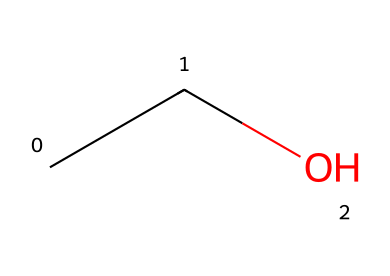What is the name of this chemical? The SMILES representation "CCO" corresponds to ethanol, a common alcohol. This is determined by recognizing the structure formed by the carbon (C) and oxygen (O) atoms in this specific arrangement.
Answer: ethanol How many carbon atoms are in the structure? The SMILES "CCO" indicates there are two carbon atoms represented by the two "C" letters at the beginning. They are connected to form a chain.
Answer: 2 What type of bond connects carbon atoms in this structure? The "CC" in the SMILES shows that the two carbon atoms are connected by a single bond, which is characteristic of alkane-type connectivity.
Answer: single bond How many hydrogen atoms are in this molecule? Each carbon typically forms four bonds; here, the first carbon is bonded to three hydrogens, and the second carbon is bonded to two hydrogens and one oxygen. Thus, the total number of hydrogen atoms is five.
Answer: 6 What functional group is present in ethanol? The presence of the "O" in the structure indicates the hydroxyl (-OH) functional group, which is characteristic of alcohols like ethanol. This functional group is essential for its classification as an alcohol.
Answer: hydroxyl group Is ethanol a flammable liquid? Ethanol is known to be a flammable liquid, and its molecular structure as a simple alcohol with carbon and hydrogen supports its classification as flammable.
Answer: yes What is the state of ethanol at room temperature? Ethanol in its pure form is a liquid at room temperature due to its molecular structure, which allows it to exist in liquid form under standard conditions.
Answer: liquid 